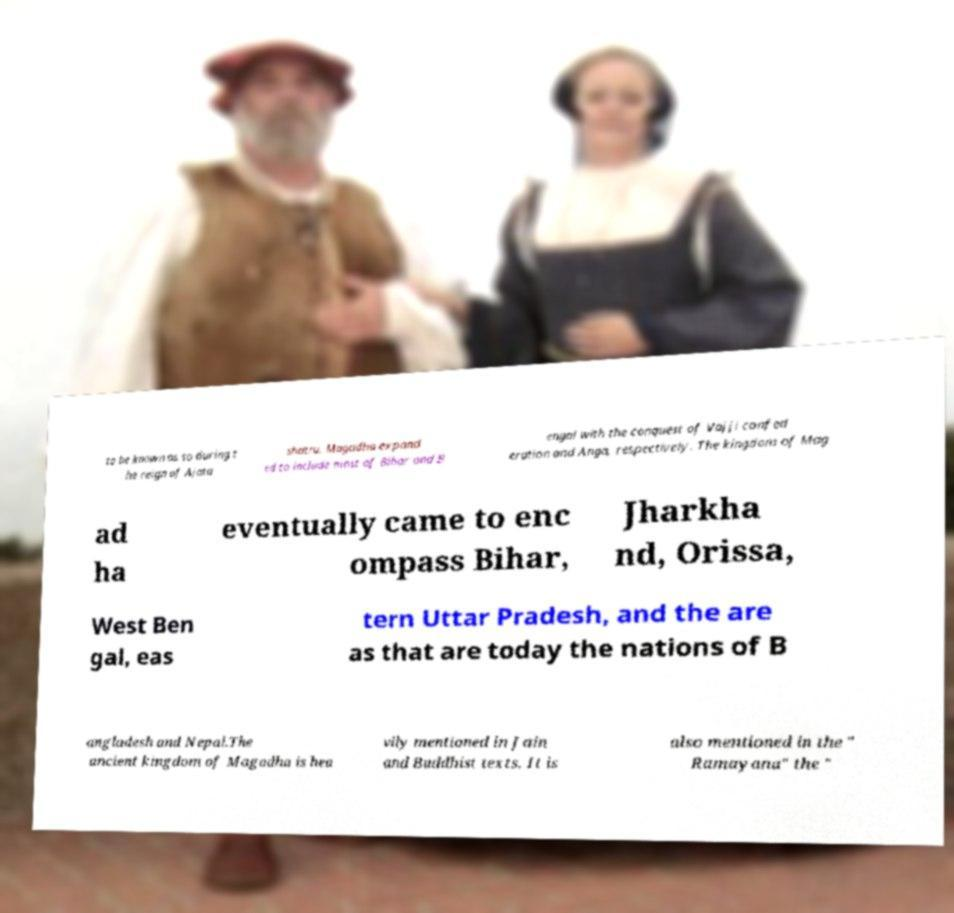For documentation purposes, I need the text within this image transcribed. Could you provide that? to be known as so during t he reign of Ajata shatru. Magadha expand ed to include most of Bihar and B engal with the conquest of Vajji confed eration and Anga, respectively. The kingdom of Mag ad ha eventually came to enc ompass Bihar, Jharkha nd, Orissa, West Ben gal, eas tern Uttar Pradesh, and the are as that are today the nations of B angladesh and Nepal.The ancient kingdom of Magadha is hea vily mentioned in Jain and Buddhist texts. It is also mentioned in the " Ramayana" the " 